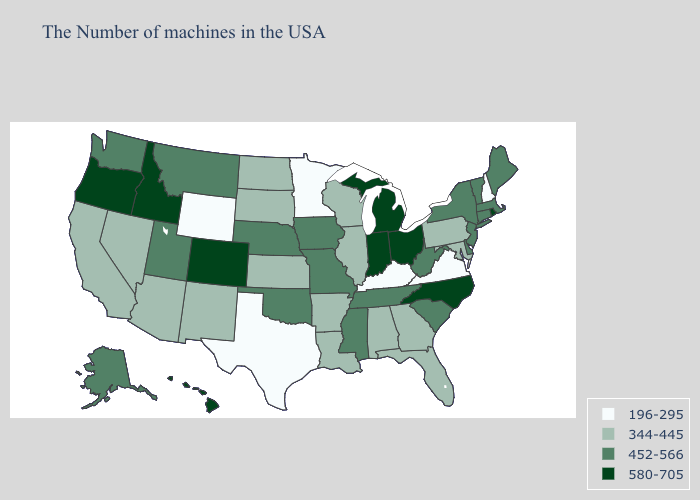What is the value of Georgia?
Short answer required. 344-445. What is the lowest value in the West?
Quick response, please. 196-295. What is the lowest value in states that border Montana?
Write a very short answer. 196-295. What is the lowest value in the South?
Answer briefly. 196-295. Name the states that have a value in the range 452-566?
Write a very short answer. Maine, Massachusetts, Vermont, Connecticut, New York, New Jersey, Delaware, South Carolina, West Virginia, Tennessee, Mississippi, Missouri, Iowa, Nebraska, Oklahoma, Utah, Montana, Washington, Alaska. What is the lowest value in states that border Wyoming?
Concise answer only. 344-445. What is the lowest value in the USA?
Give a very brief answer. 196-295. Does New York have a lower value than Alaska?
Concise answer only. No. Name the states that have a value in the range 580-705?
Answer briefly. Rhode Island, North Carolina, Ohio, Michigan, Indiana, Colorado, Idaho, Oregon, Hawaii. What is the value of Missouri?
Short answer required. 452-566. What is the value of Pennsylvania?
Write a very short answer. 344-445. Does the map have missing data?
Be succinct. No. What is the lowest value in the South?
Give a very brief answer. 196-295. Name the states that have a value in the range 580-705?
Answer briefly. Rhode Island, North Carolina, Ohio, Michigan, Indiana, Colorado, Idaho, Oregon, Hawaii. Name the states that have a value in the range 452-566?
Write a very short answer. Maine, Massachusetts, Vermont, Connecticut, New York, New Jersey, Delaware, South Carolina, West Virginia, Tennessee, Mississippi, Missouri, Iowa, Nebraska, Oklahoma, Utah, Montana, Washington, Alaska. 